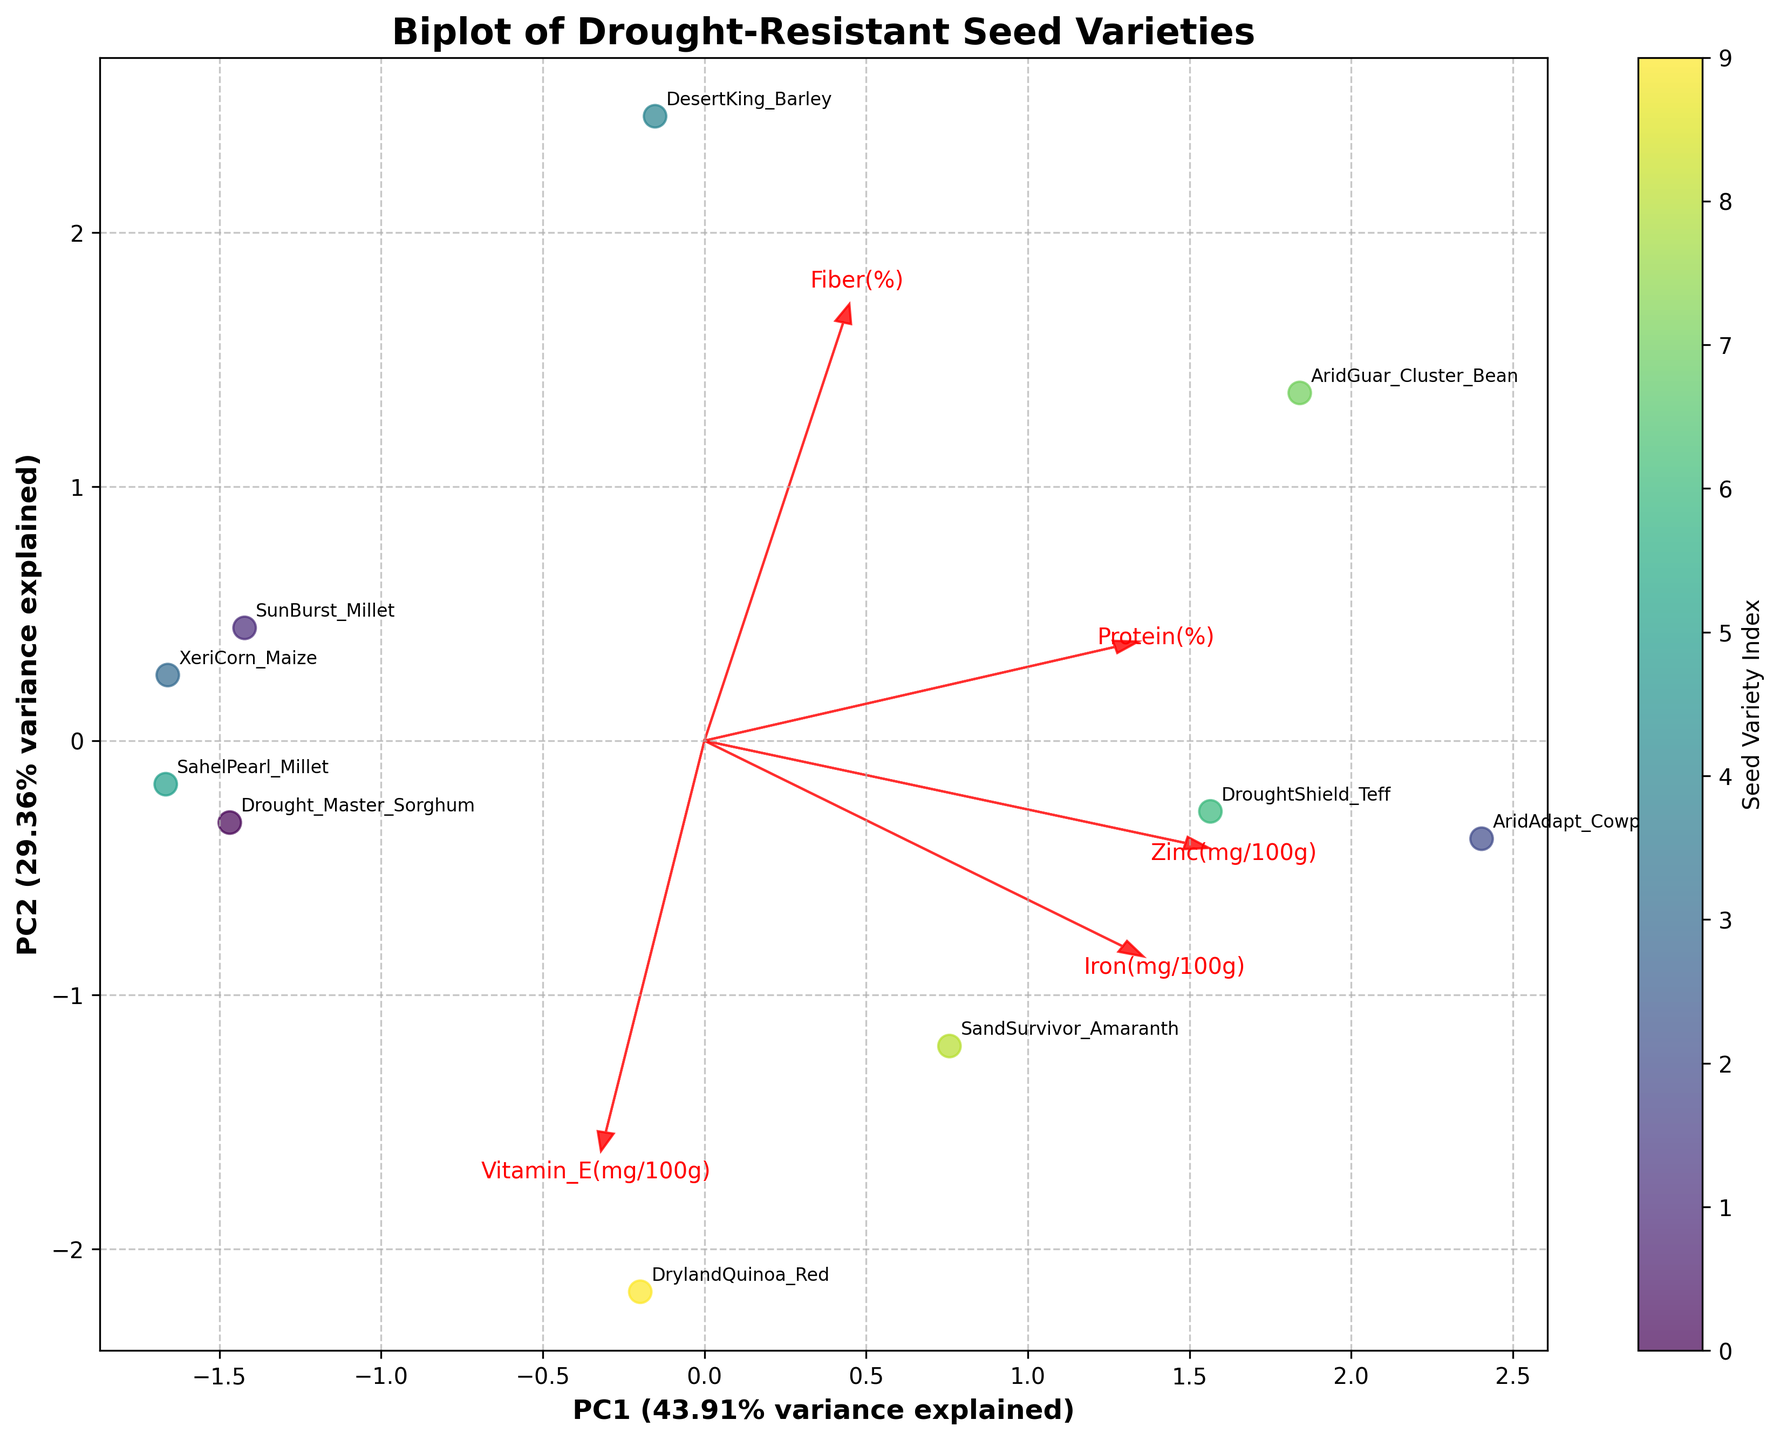How many seed varieties are plotted in the figure? There are individual points labeled with seed variety names on the plot. Count them to find the total number of seed varieties.
Answer: 10 Which two seed varieties are closest to each other in the plot, and what does this indicate? Look for the labels that are spatially nearest to each other. This indicates that these two seed varieties have similar nutrient compositions.
Answer: Drought_Master_Sorghum and SandSurvivor_Amaranth Which nutrient shows the highest loading on the first principal component (PC1)? Observe the arrows showing nutrient loadings. The arrow with the longest length in the horizontal (PC1) direction indicates the nutrient with the highest loading.
Answer: Fiber(%) Which seed variety is the most distinct from others based on the plot? Identify the point that is furthest from the cluster of other points. This implies the seed has a unique nutrient profile compared to others.
Answer: AridGuar_Cluster_Bean What percentage of the total variance is explained by the first two principal components (PC1 and PC2)? Look at the axis labels that mention the explained variance for PC1 and PC2. Add these values to get the total variance explained by the first two components.
Answer: 100% Which nutrient has the smallest impact on the second principal component (PC2) and how can you tell? Find the arrow that has the shortest length in the vertical (PC2) direction. This arrow indicates the nutrient with the smallest contribution to PC2.
Answer: Vitamin_E(mg/100g) Compare the protein content between DroughtShield_Teff and SunBurst_Millet based on their positions on the plot. Look at the positions of DroughtShield_Teff and SunBurst_Millet relative to the Protein(%) arrow. The point closer to the direction of the arrow indicates higher protein content.
Answer: DroughtShield_Teff has higher protein Which seed variety appears to have a balanced nutrient composition across multiple dimensions? Look for a point near the origin where nutrient arrows converge, indicating balanced values across multiple nutrients.
Answer: DrylandQuinoa_Red How does the fiber content of DesertKing_Barley compare to other seed varieties? Observe the position of DesertKing_Barley relative to the Fiber(%) arrow. Compare its distance to others to determine if it is higher or lower in fiber content.
Answer: Higher fiber content What insight can you draw about the variability of nutrient profiles among the seed varieties? Consider the spread of points and the lengths of arrows. A wide spread and long arrows indicate high variability in nutrient profiles across seed varieties. Interpret the variability based on this observation.
Answer: High variability in nutrient profiles 